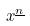<formula> <loc_0><loc_0><loc_500><loc_500>x ^ { \underline { n } }</formula> 